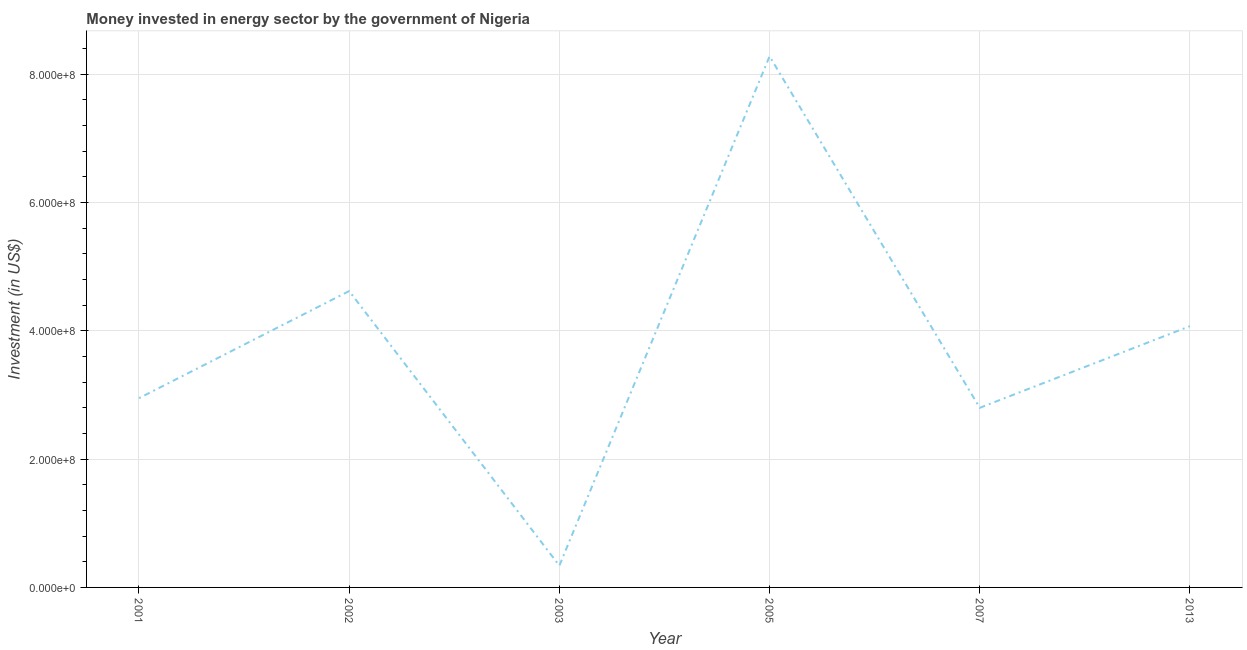What is the investment in energy in 2001?
Your answer should be very brief. 2.95e+08. Across all years, what is the maximum investment in energy?
Your answer should be compact. 8.28e+08. Across all years, what is the minimum investment in energy?
Make the answer very short. 3.40e+07. What is the sum of the investment in energy?
Make the answer very short. 2.31e+09. What is the difference between the investment in energy in 2003 and 2005?
Keep it short and to the point. -7.94e+08. What is the average investment in energy per year?
Offer a terse response. 3.84e+08. What is the median investment in energy?
Make the answer very short. 3.51e+08. In how many years, is the investment in energy greater than 200000000 US$?
Ensure brevity in your answer.  5. Do a majority of the years between 2003 and 2005 (inclusive) have investment in energy greater than 80000000 US$?
Your response must be concise. No. What is the ratio of the investment in energy in 2002 to that in 2007?
Your answer should be very brief. 1.65. What is the difference between the highest and the second highest investment in energy?
Provide a succinct answer. 3.66e+08. What is the difference between the highest and the lowest investment in energy?
Keep it short and to the point. 7.94e+08. In how many years, is the investment in energy greater than the average investment in energy taken over all years?
Your answer should be compact. 3. How many lines are there?
Keep it short and to the point. 1. What is the difference between two consecutive major ticks on the Y-axis?
Provide a succinct answer. 2.00e+08. Are the values on the major ticks of Y-axis written in scientific E-notation?
Your answer should be compact. Yes. What is the title of the graph?
Give a very brief answer. Money invested in energy sector by the government of Nigeria. What is the label or title of the Y-axis?
Offer a very short reply. Investment (in US$). What is the Investment (in US$) in 2001?
Your answer should be very brief. 2.95e+08. What is the Investment (in US$) in 2002?
Give a very brief answer. 4.62e+08. What is the Investment (in US$) in 2003?
Provide a short and direct response. 3.40e+07. What is the Investment (in US$) of 2005?
Your answer should be very brief. 8.28e+08. What is the Investment (in US$) of 2007?
Make the answer very short. 2.80e+08. What is the Investment (in US$) of 2013?
Provide a succinct answer. 4.07e+08. What is the difference between the Investment (in US$) in 2001 and 2002?
Your answer should be very brief. -1.67e+08. What is the difference between the Investment (in US$) in 2001 and 2003?
Offer a terse response. 2.61e+08. What is the difference between the Investment (in US$) in 2001 and 2005?
Offer a very short reply. -5.33e+08. What is the difference between the Investment (in US$) in 2001 and 2007?
Offer a terse response. 1.50e+07. What is the difference between the Investment (in US$) in 2001 and 2013?
Offer a terse response. -1.12e+08. What is the difference between the Investment (in US$) in 2002 and 2003?
Provide a succinct answer. 4.28e+08. What is the difference between the Investment (in US$) in 2002 and 2005?
Your answer should be compact. -3.66e+08. What is the difference between the Investment (in US$) in 2002 and 2007?
Make the answer very short. 1.82e+08. What is the difference between the Investment (in US$) in 2002 and 2013?
Provide a succinct answer. 5.47e+07. What is the difference between the Investment (in US$) in 2003 and 2005?
Your answer should be compact. -7.94e+08. What is the difference between the Investment (in US$) in 2003 and 2007?
Offer a terse response. -2.46e+08. What is the difference between the Investment (in US$) in 2003 and 2013?
Provide a succinct answer. -3.73e+08. What is the difference between the Investment (in US$) in 2005 and 2007?
Your answer should be very brief. 5.48e+08. What is the difference between the Investment (in US$) in 2005 and 2013?
Your answer should be compact. 4.21e+08. What is the difference between the Investment (in US$) in 2007 and 2013?
Give a very brief answer. -1.27e+08. What is the ratio of the Investment (in US$) in 2001 to that in 2002?
Ensure brevity in your answer.  0.64. What is the ratio of the Investment (in US$) in 2001 to that in 2003?
Your answer should be very brief. 8.68. What is the ratio of the Investment (in US$) in 2001 to that in 2005?
Keep it short and to the point. 0.36. What is the ratio of the Investment (in US$) in 2001 to that in 2007?
Your answer should be very brief. 1.05. What is the ratio of the Investment (in US$) in 2001 to that in 2013?
Your response must be concise. 0.72. What is the ratio of the Investment (in US$) in 2002 to that in 2003?
Your response must be concise. 13.59. What is the ratio of the Investment (in US$) in 2002 to that in 2005?
Provide a succinct answer. 0.56. What is the ratio of the Investment (in US$) in 2002 to that in 2007?
Your answer should be compact. 1.65. What is the ratio of the Investment (in US$) in 2002 to that in 2013?
Offer a very short reply. 1.13. What is the ratio of the Investment (in US$) in 2003 to that in 2005?
Your answer should be very brief. 0.04. What is the ratio of the Investment (in US$) in 2003 to that in 2007?
Ensure brevity in your answer.  0.12. What is the ratio of the Investment (in US$) in 2003 to that in 2013?
Provide a short and direct response. 0.08. What is the ratio of the Investment (in US$) in 2005 to that in 2007?
Offer a terse response. 2.96. What is the ratio of the Investment (in US$) in 2005 to that in 2013?
Your answer should be compact. 2.03. What is the ratio of the Investment (in US$) in 2007 to that in 2013?
Keep it short and to the point. 0.69. 